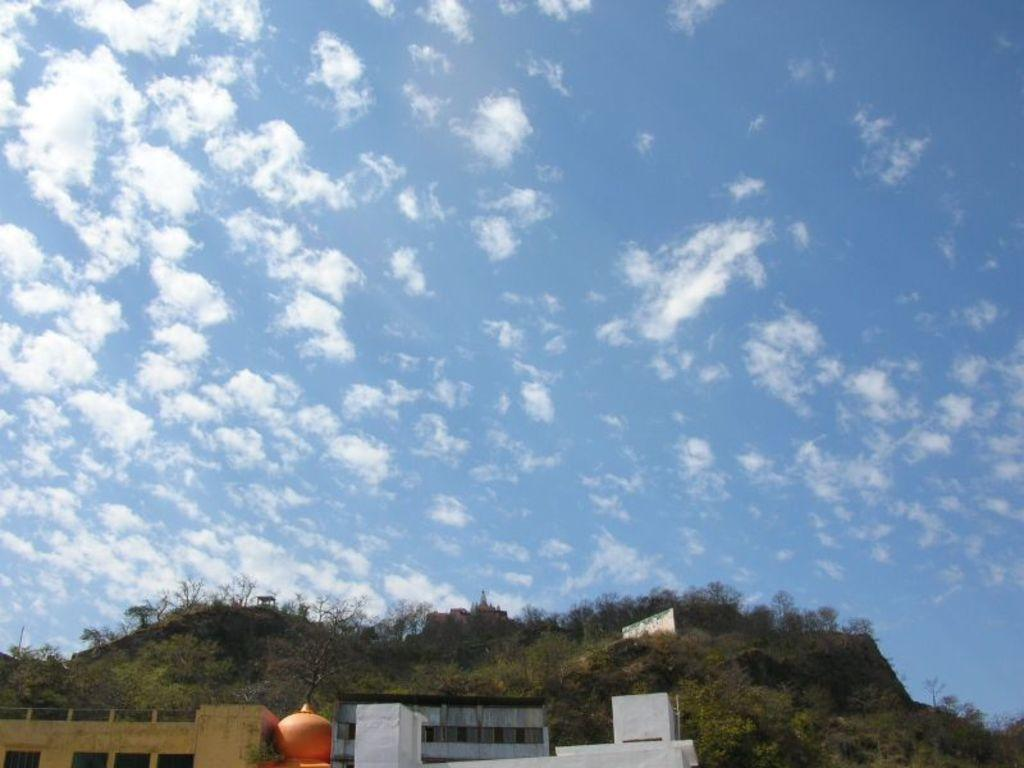What structures can be seen in the image? There are buildings in the image. What type of natural feature is visible in the background of the image? There are trees on a hill in the background of the image. What type of silk is being used to make the example in the image? There is no example or silk present in the image. What type of grass is growing on the hill in the image? The provided facts do not mention any grass on the hill; only trees are mentioned. 